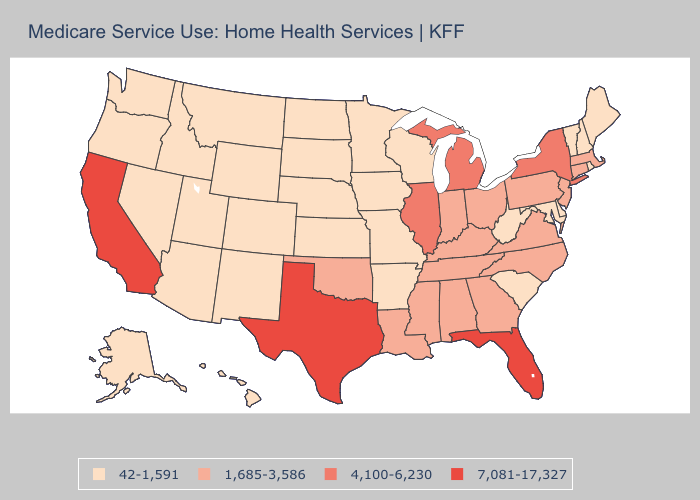Does Connecticut have the lowest value in the Northeast?
Quick response, please. No. What is the lowest value in the MidWest?
Concise answer only. 42-1,591. Does Florida have the highest value in the USA?
Short answer required. Yes. Name the states that have a value in the range 7,081-17,327?
Give a very brief answer. California, Florida, Texas. What is the lowest value in states that border New Mexico?
Write a very short answer. 42-1,591. What is the value of Connecticut?
Give a very brief answer. 1,685-3,586. Does Delaware have a lower value than West Virginia?
Give a very brief answer. No. Does Utah have the lowest value in the USA?
Give a very brief answer. Yes. Name the states that have a value in the range 4,100-6,230?
Quick response, please. Illinois, Michigan, New York. What is the highest value in the USA?
Answer briefly. 7,081-17,327. Among the states that border Texas , which have the lowest value?
Be succinct. Arkansas, New Mexico. What is the lowest value in states that border Virginia?
Quick response, please. 42-1,591. Does Oklahoma have the same value as Pennsylvania?
Give a very brief answer. Yes. Does New Jersey have a higher value than Missouri?
Be succinct. Yes. Name the states that have a value in the range 4,100-6,230?
Keep it brief. Illinois, Michigan, New York. 